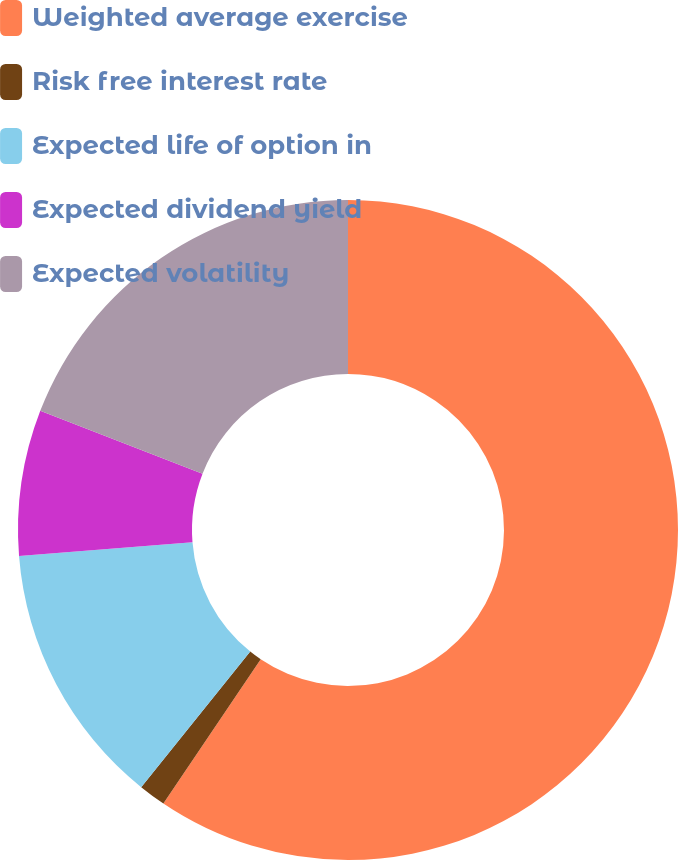Convert chart to OTSL. <chart><loc_0><loc_0><loc_500><loc_500><pie_chart><fcel>Weighted average exercise<fcel>Risk free interest rate<fcel>Expected life of option in<fcel>Expected dividend yield<fcel>Expected volatility<nl><fcel>59.45%<fcel>1.33%<fcel>12.96%<fcel>7.14%<fcel>19.12%<nl></chart> 